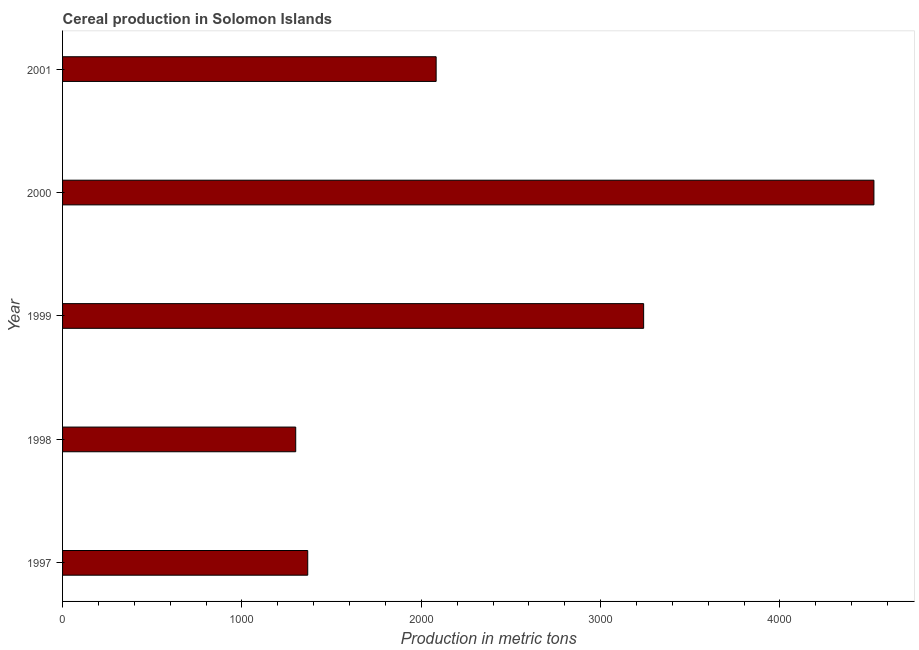What is the title of the graph?
Your answer should be very brief. Cereal production in Solomon Islands. What is the label or title of the X-axis?
Ensure brevity in your answer.  Production in metric tons. What is the cereal production in 2001?
Your response must be concise. 2083. Across all years, what is the maximum cereal production?
Your response must be concise. 4524. Across all years, what is the minimum cereal production?
Keep it short and to the point. 1300. In which year was the cereal production maximum?
Ensure brevity in your answer.  2000. What is the sum of the cereal production?
Provide a succinct answer. 1.25e+04. What is the difference between the cereal production in 1998 and 1999?
Give a very brief answer. -1940. What is the average cereal production per year?
Provide a short and direct response. 2502. What is the median cereal production?
Provide a succinct answer. 2083. Do a majority of the years between 1998 and 2001 (inclusive) have cereal production greater than 3000 metric tons?
Provide a succinct answer. No. What is the ratio of the cereal production in 1998 to that in 1999?
Provide a short and direct response. 0.4. What is the difference between the highest and the second highest cereal production?
Provide a short and direct response. 1284. What is the difference between the highest and the lowest cereal production?
Offer a very short reply. 3224. In how many years, is the cereal production greater than the average cereal production taken over all years?
Your answer should be compact. 2. What is the Production in metric tons in 1997?
Provide a succinct answer. 1367. What is the Production in metric tons in 1998?
Your answer should be compact. 1300. What is the Production in metric tons in 1999?
Offer a very short reply. 3240. What is the Production in metric tons in 2000?
Ensure brevity in your answer.  4524. What is the Production in metric tons of 2001?
Offer a very short reply. 2083. What is the difference between the Production in metric tons in 1997 and 1998?
Your answer should be very brief. 67. What is the difference between the Production in metric tons in 1997 and 1999?
Ensure brevity in your answer.  -1873. What is the difference between the Production in metric tons in 1997 and 2000?
Make the answer very short. -3157. What is the difference between the Production in metric tons in 1997 and 2001?
Ensure brevity in your answer.  -716. What is the difference between the Production in metric tons in 1998 and 1999?
Your answer should be compact. -1940. What is the difference between the Production in metric tons in 1998 and 2000?
Offer a very short reply. -3224. What is the difference between the Production in metric tons in 1998 and 2001?
Offer a terse response. -783. What is the difference between the Production in metric tons in 1999 and 2000?
Your response must be concise. -1284. What is the difference between the Production in metric tons in 1999 and 2001?
Give a very brief answer. 1157. What is the difference between the Production in metric tons in 2000 and 2001?
Make the answer very short. 2441. What is the ratio of the Production in metric tons in 1997 to that in 1998?
Ensure brevity in your answer.  1.05. What is the ratio of the Production in metric tons in 1997 to that in 1999?
Give a very brief answer. 0.42. What is the ratio of the Production in metric tons in 1997 to that in 2000?
Offer a terse response. 0.3. What is the ratio of the Production in metric tons in 1997 to that in 2001?
Provide a succinct answer. 0.66. What is the ratio of the Production in metric tons in 1998 to that in 1999?
Offer a terse response. 0.4. What is the ratio of the Production in metric tons in 1998 to that in 2000?
Offer a very short reply. 0.29. What is the ratio of the Production in metric tons in 1998 to that in 2001?
Ensure brevity in your answer.  0.62. What is the ratio of the Production in metric tons in 1999 to that in 2000?
Offer a very short reply. 0.72. What is the ratio of the Production in metric tons in 1999 to that in 2001?
Provide a succinct answer. 1.55. What is the ratio of the Production in metric tons in 2000 to that in 2001?
Your answer should be compact. 2.17. 